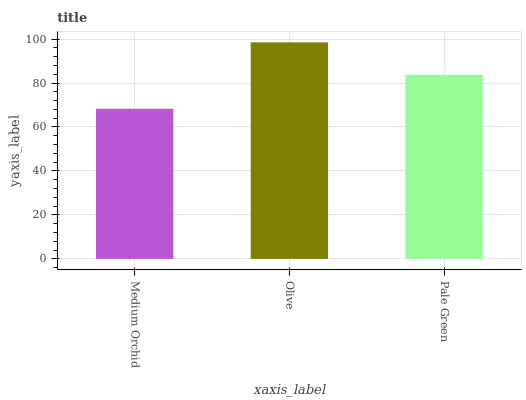Is Pale Green the minimum?
Answer yes or no. No. Is Pale Green the maximum?
Answer yes or no. No. Is Olive greater than Pale Green?
Answer yes or no. Yes. Is Pale Green less than Olive?
Answer yes or no. Yes. Is Pale Green greater than Olive?
Answer yes or no. No. Is Olive less than Pale Green?
Answer yes or no. No. Is Pale Green the high median?
Answer yes or no. Yes. Is Pale Green the low median?
Answer yes or no. Yes. Is Medium Orchid the high median?
Answer yes or no. No. Is Olive the low median?
Answer yes or no. No. 